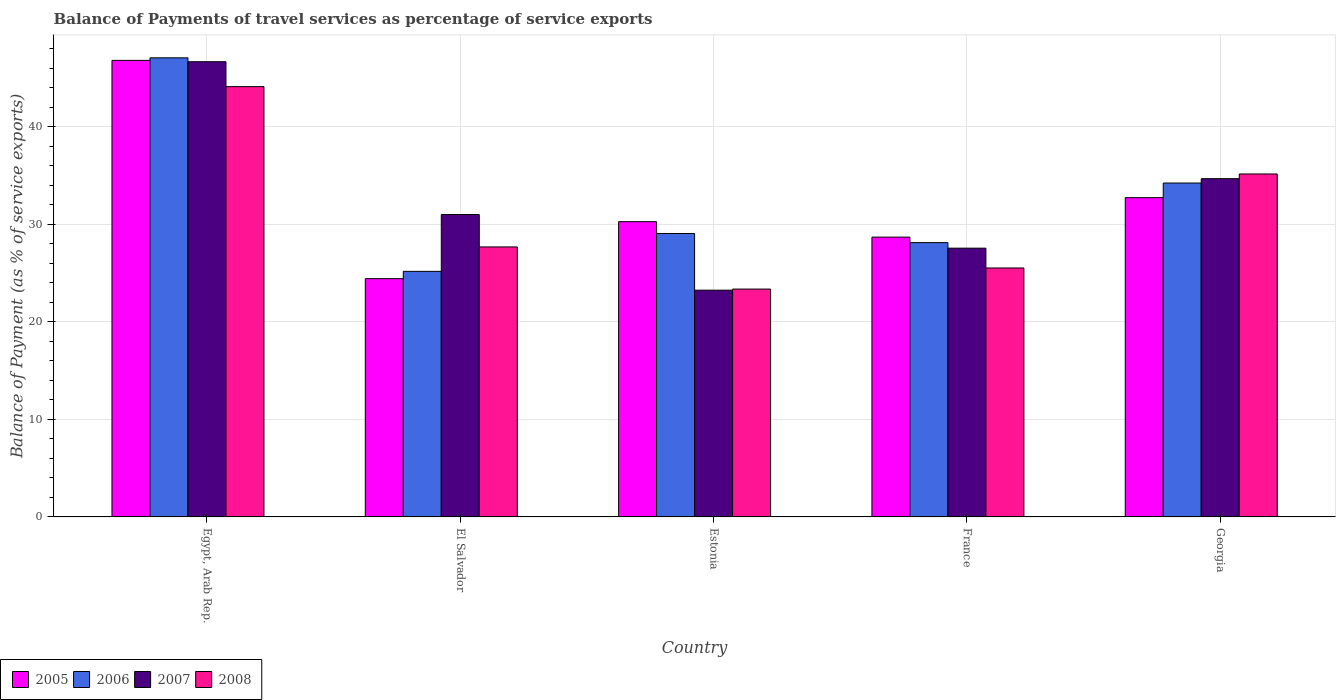Are the number of bars on each tick of the X-axis equal?
Offer a very short reply. Yes. How many bars are there on the 3rd tick from the left?
Your answer should be very brief. 4. What is the label of the 1st group of bars from the left?
Your response must be concise. Egypt, Arab Rep. In how many cases, is the number of bars for a given country not equal to the number of legend labels?
Your response must be concise. 0. What is the balance of payments of travel services in 2008 in Georgia?
Provide a short and direct response. 35.15. Across all countries, what is the maximum balance of payments of travel services in 2005?
Your response must be concise. 46.79. Across all countries, what is the minimum balance of payments of travel services in 2006?
Your answer should be compact. 25.17. In which country was the balance of payments of travel services in 2005 maximum?
Provide a short and direct response. Egypt, Arab Rep. In which country was the balance of payments of travel services in 2008 minimum?
Your answer should be compact. Estonia. What is the total balance of payments of travel services in 2007 in the graph?
Offer a very short reply. 163.08. What is the difference between the balance of payments of travel services in 2006 in El Salvador and that in France?
Offer a terse response. -2.95. What is the difference between the balance of payments of travel services in 2005 in France and the balance of payments of travel services in 2008 in Georgia?
Provide a short and direct response. -6.47. What is the average balance of payments of travel services in 2008 per country?
Keep it short and to the point. 31.15. What is the difference between the balance of payments of travel services of/in 2007 and balance of payments of travel services of/in 2006 in El Salvador?
Provide a short and direct response. 5.82. What is the ratio of the balance of payments of travel services in 2008 in Egypt, Arab Rep. to that in Georgia?
Offer a terse response. 1.25. Is the balance of payments of travel services in 2005 in Egypt, Arab Rep. less than that in France?
Provide a short and direct response. No. What is the difference between the highest and the second highest balance of payments of travel services in 2006?
Keep it short and to the point. 5.17. What is the difference between the highest and the lowest balance of payments of travel services in 2008?
Offer a terse response. 20.74. In how many countries, is the balance of payments of travel services in 2008 greater than the average balance of payments of travel services in 2008 taken over all countries?
Provide a short and direct response. 2. What does the 2nd bar from the left in El Salvador represents?
Offer a terse response. 2006. What does the 4th bar from the right in Egypt, Arab Rep. represents?
Your answer should be compact. 2005. Are all the bars in the graph horizontal?
Keep it short and to the point. No. Are the values on the major ticks of Y-axis written in scientific E-notation?
Your response must be concise. No. How many legend labels are there?
Give a very brief answer. 4. What is the title of the graph?
Your answer should be compact. Balance of Payments of travel services as percentage of service exports. What is the label or title of the Y-axis?
Your answer should be compact. Balance of Payment (as % of service exports). What is the Balance of Payment (as % of service exports) in 2005 in Egypt, Arab Rep.?
Offer a very short reply. 46.79. What is the Balance of Payment (as % of service exports) of 2006 in Egypt, Arab Rep.?
Your answer should be compact. 47.05. What is the Balance of Payment (as % of service exports) in 2007 in Egypt, Arab Rep.?
Provide a succinct answer. 46.65. What is the Balance of Payment (as % of service exports) in 2008 in Egypt, Arab Rep.?
Your response must be concise. 44.09. What is the Balance of Payment (as % of service exports) of 2005 in El Salvador?
Provide a succinct answer. 24.42. What is the Balance of Payment (as % of service exports) in 2006 in El Salvador?
Make the answer very short. 25.17. What is the Balance of Payment (as % of service exports) in 2007 in El Salvador?
Provide a succinct answer. 30.99. What is the Balance of Payment (as % of service exports) of 2008 in El Salvador?
Your response must be concise. 27.67. What is the Balance of Payment (as % of service exports) in 2005 in Estonia?
Offer a very short reply. 30.26. What is the Balance of Payment (as % of service exports) in 2006 in Estonia?
Ensure brevity in your answer.  29.04. What is the Balance of Payment (as % of service exports) in 2007 in Estonia?
Offer a very short reply. 23.24. What is the Balance of Payment (as % of service exports) of 2008 in Estonia?
Your answer should be compact. 23.35. What is the Balance of Payment (as % of service exports) in 2005 in France?
Ensure brevity in your answer.  28.67. What is the Balance of Payment (as % of service exports) in 2006 in France?
Offer a terse response. 28.11. What is the Balance of Payment (as % of service exports) in 2007 in France?
Your answer should be very brief. 27.54. What is the Balance of Payment (as % of service exports) in 2008 in France?
Make the answer very short. 25.51. What is the Balance of Payment (as % of service exports) of 2005 in Georgia?
Make the answer very short. 32.72. What is the Balance of Payment (as % of service exports) in 2006 in Georgia?
Offer a very short reply. 34.22. What is the Balance of Payment (as % of service exports) of 2007 in Georgia?
Your answer should be very brief. 34.66. What is the Balance of Payment (as % of service exports) of 2008 in Georgia?
Provide a succinct answer. 35.15. Across all countries, what is the maximum Balance of Payment (as % of service exports) in 2005?
Offer a very short reply. 46.79. Across all countries, what is the maximum Balance of Payment (as % of service exports) of 2006?
Offer a terse response. 47.05. Across all countries, what is the maximum Balance of Payment (as % of service exports) of 2007?
Provide a succinct answer. 46.65. Across all countries, what is the maximum Balance of Payment (as % of service exports) of 2008?
Provide a short and direct response. 44.09. Across all countries, what is the minimum Balance of Payment (as % of service exports) of 2005?
Your response must be concise. 24.42. Across all countries, what is the minimum Balance of Payment (as % of service exports) in 2006?
Give a very brief answer. 25.17. Across all countries, what is the minimum Balance of Payment (as % of service exports) in 2007?
Your answer should be compact. 23.24. Across all countries, what is the minimum Balance of Payment (as % of service exports) in 2008?
Your answer should be compact. 23.35. What is the total Balance of Payment (as % of service exports) of 2005 in the graph?
Ensure brevity in your answer.  162.86. What is the total Balance of Payment (as % of service exports) of 2006 in the graph?
Offer a very short reply. 163.58. What is the total Balance of Payment (as % of service exports) of 2007 in the graph?
Provide a short and direct response. 163.08. What is the total Balance of Payment (as % of service exports) in 2008 in the graph?
Provide a succinct answer. 155.77. What is the difference between the Balance of Payment (as % of service exports) of 2005 in Egypt, Arab Rep. and that in El Salvador?
Offer a very short reply. 22.37. What is the difference between the Balance of Payment (as % of service exports) in 2006 in Egypt, Arab Rep. and that in El Salvador?
Make the answer very short. 21.88. What is the difference between the Balance of Payment (as % of service exports) of 2007 in Egypt, Arab Rep. and that in El Salvador?
Ensure brevity in your answer.  15.66. What is the difference between the Balance of Payment (as % of service exports) of 2008 in Egypt, Arab Rep. and that in El Salvador?
Provide a succinct answer. 16.43. What is the difference between the Balance of Payment (as % of service exports) of 2005 in Egypt, Arab Rep. and that in Estonia?
Your answer should be very brief. 16.53. What is the difference between the Balance of Payment (as % of service exports) of 2006 in Egypt, Arab Rep. and that in Estonia?
Ensure brevity in your answer.  18. What is the difference between the Balance of Payment (as % of service exports) of 2007 in Egypt, Arab Rep. and that in Estonia?
Make the answer very short. 23.41. What is the difference between the Balance of Payment (as % of service exports) of 2008 in Egypt, Arab Rep. and that in Estonia?
Offer a very short reply. 20.74. What is the difference between the Balance of Payment (as % of service exports) in 2005 in Egypt, Arab Rep. and that in France?
Make the answer very short. 18.11. What is the difference between the Balance of Payment (as % of service exports) of 2006 in Egypt, Arab Rep. and that in France?
Your answer should be compact. 18.94. What is the difference between the Balance of Payment (as % of service exports) of 2007 in Egypt, Arab Rep. and that in France?
Make the answer very short. 19.11. What is the difference between the Balance of Payment (as % of service exports) in 2008 in Egypt, Arab Rep. and that in France?
Your response must be concise. 18.58. What is the difference between the Balance of Payment (as % of service exports) of 2005 in Egypt, Arab Rep. and that in Georgia?
Keep it short and to the point. 14.07. What is the difference between the Balance of Payment (as % of service exports) of 2006 in Egypt, Arab Rep. and that in Georgia?
Give a very brief answer. 12.83. What is the difference between the Balance of Payment (as % of service exports) of 2007 in Egypt, Arab Rep. and that in Georgia?
Your answer should be compact. 11.98. What is the difference between the Balance of Payment (as % of service exports) of 2008 in Egypt, Arab Rep. and that in Georgia?
Your response must be concise. 8.95. What is the difference between the Balance of Payment (as % of service exports) in 2005 in El Salvador and that in Estonia?
Ensure brevity in your answer.  -5.84. What is the difference between the Balance of Payment (as % of service exports) in 2006 in El Salvador and that in Estonia?
Offer a very short reply. -3.88. What is the difference between the Balance of Payment (as % of service exports) in 2007 in El Salvador and that in Estonia?
Your response must be concise. 7.75. What is the difference between the Balance of Payment (as % of service exports) of 2008 in El Salvador and that in Estonia?
Give a very brief answer. 4.32. What is the difference between the Balance of Payment (as % of service exports) in 2005 in El Salvador and that in France?
Keep it short and to the point. -4.26. What is the difference between the Balance of Payment (as % of service exports) of 2006 in El Salvador and that in France?
Your answer should be compact. -2.95. What is the difference between the Balance of Payment (as % of service exports) of 2007 in El Salvador and that in France?
Offer a very short reply. 3.45. What is the difference between the Balance of Payment (as % of service exports) of 2008 in El Salvador and that in France?
Offer a terse response. 2.16. What is the difference between the Balance of Payment (as % of service exports) in 2005 in El Salvador and that in Georgia?
Offer a very short reply. -8.3. What is the difference between the Balance of Payment (as % of service exports) in 2006 in El Salvador and that in Georgia?
Your answer should be compact. -9.05. What is the difference between the Balance of Payment (as % of service exports) in 2007 in El Salvador and that in Georgia?
Offer a very short reply. -3.67. What is the difference between the Balance of Payment (as % of service exports) in 2008 in El Salvador and that in Georgia?
Offer a very short reply. -7.48. What is the difference between the Balance of Payment (as % of service exports) of 2005 in Estonia and that in France?
Offer a terse response. 1.58. What is the difference between the Balance of Payment (as % of service exports) in 2006 in Estonia and that in France?
Your answer should be compact. 0.93. What is the difference between the Balance of Payment (as % of service exports) of 2007 in Estonia and that in France?
Your response must be concise. -4.31. What is the difference between the Balance of Payment (as % of service exports) in 2008 in Estonia and that in France?
Offer a very short reply. -2.16. What is the difference between the Balance of Payment (as % of service exports) in 2005 in Estonia and that in Georgia?
Give a very brief answer. -2.46. What is the difference between the Balance of Payment (as % of service exports) in 2006 in Estonia and that in Georgia?
Offer a terse response. -5.17. What is the difference between the Balance of Payment (as % of service exports) in 2007 in Estonia and that in Georgia?
Keep it short and to the point. -11.43. What is the difference between the Balance of Payment (as % of service exports) of 2008 in Estonia and that in Georgia?
Keep it short and to the point. -11.79. What is the difference between the Balance of Payment (as % of service exports) of 2005 in France and that in Georgia?
Ensure brevity in your answer.  -4.05. What is the difference between the Balance of Payment (as % of service exports) in 2006 in France and that in Georgia?
Your answer should be compact. -6.11. What is the difference between the Balance of Payment (as % of service exports) in 2007 in France and that in Georgia?
Give a very brief answer. -7.12. What is the difference between the Balance of Payment (as % of service exports) in 2008 in France and that in Georgia?
Provide a succinct answer. -9.63. What is the difference between the Balance of Payment (as % of service exports) in 2005 in Egypt, Arab Rep. and the Balance of Payment (as % of service exports) in 2006 in El Salvador?
Your answer should be compact. 21.62. What is the difference between the Balance of Payment (as % of service exports) of 2005 in Egypt, Arab Rep. and the Balance of Payment (as % of service exports) of 2007 in El Salvador?
Make the answer very short. 15.8. What is the difference between the Balance of Payment (as % of service exports) in 2005 in Egypt, Arab Rep. and the Balance of Payment (as % of service exports) in 2008 in El Salvador?
Offer a terse response. 19.12. What is the difference between the Balance of Payment (as % of service exports) of 2006 in Egypt, Arab Rep. and the Balance of Payment (as % of service exports) of 2007 in El Salvador?
Ensure brevity in your answer.  16.06. What is the difference between the Balance of Payment (as % of service exports) in 2006 in Egypt, Arab Rep. and the Balance of Payment (as % of service exports) in 2008 in El Salvador?
Offer a very short reply. 19.38. What is the difference between the Balance of Payment (as % of service exports) in 2007 in Egypt, Arab Rep. and the Balance of Payment (as % of service exports) in 2008 in El Salvador?
Your response must be concise. 18.98. What is the difference between the Balance of Payment (as % of service exports) in 2005 in Egypt, Arab Rep. and the Balance of Payment (as % of service exports) in 2006 in Estonia?
Offer a very short reply. 17.74. What is the difference between the Balance of Payment (as % of service exports) in 2005 in Egypt, Arab Rep. and the Balance of Payment (as % of service exports) in 2007 in Estonia?
Provide a succinct answer. 23.55. What is the difference between the Balance of Payment (as % of service exports) of 2005 in Egypt, Arab Rep. and the Balance of Payment (as % of service exports) of 2008 in Estonia?
Offer a terse response. 23.43. What is the difference between the Balance of Payment (as % of service exports) of 2006 in Egypt, Arab Rep. and the Balance of Payment (as % of service exports) of 2007 in Estonia?
Offer a terse response. 23.81. What is the difference between the Balance of Payment (as % of service exports) in 2006 in Egypt, Arab Rep. and the Balance of Payment (as % of service exports) in 2008 in Estonia?
Offer a terse response. 23.7. What is the difference between the Balance of Payment (as % of service exports) of 2007 in Egypt, Arab Rep. and the Balance of Payment (as % of service exports) of 2008 in Estonia?
Offer a terse response. 23.3. What is the difference between the Balance of Payment (as % of service exports) of 2005 in Egypt, Arab Rep. and the Balance of Payment (as % of service exports) of 2006 in France?
Keep it short and to the point. 18.67. What is the difference between the Balance of Payment (as % of service exports) of 2005 in Egypt, Arab Rep. and the Balance of Payment (as % of service exports) of 2007 in France?
Offer a very short reply. 19.24. What is the difference between the Balance of Payment (as % of service exports) of 2005 in Egypt, Arab Rep. and the Balance of Payment (as % of service exports) of 2008 in France?
Offer a terse response. 21.27. What is the difference between the Balance of Payment (as % of service exports) of 2006 in Egypt, Arab Rep. and the Balance of Payment (as % of service exports) of 2007 in France?
Provide a succinct answer. 19.5. What is the difference between the Balance of Payment (as % of service exports) of 2006 in Egypt, Arab Rep. and the Balance of Payment (as % of service exports) of 2008 in France?
Provide a succinct answer. 21.53. What is the difference between the Balance of Payment (as % of service exports) in 2007 in Egypt, Arab Rep. and the Balance of Payment (as % of service exports) in 2008 in France?
Give a very brief answer. 21.14. What is the difference between the Balance of Payment (as % of service exports) of 2005 in Egypt, Arab Rep. and the Balance of Payment (as % of service exports) of 2006 in Georgia?
Your answer should be very brief. 12.57. What is the difference between the Balance of Payment (as % of service exports) in 2005 in Egypt, Arab Rep. and the Balance of Payment (as % of service exports) in 2007 in Georgia?
Provide a short and direct response. 12.12. What is the difference between the Balance of Payment (as % of service exports) in 2005 in Egypt, Arab Rep. and the Balance of Payment (as % of service exports) in 2008 in Georgia?
Ensure brevity in your answer.  11.64. What is the difference between the Balance of Payment (as % of service exports) in 2006 in Egypt, Arab Rep. and the Balance of Payment (as % of service exports) in 2007 in Georgia?
Keep it short and to the point. 12.38. What is the difference between the Balance of Payment (as % of service exports) of 2006 in Egypt, Arab Rep. and the Balance of Payment (as % of service exports) of 2008 in Georgia?
Ensure brevity in your answer.  11.9. What is the difference between the Balance of Payment (as % of service exports) of 2007 in Egypt, Arab Rep. and the Balance of Payment (as % of service exports) of 2008 in Georgia?
Provide a short and direct response. 11.5. What is the difference between the Balance of Payment (as % of service exports) of 2005 in El Salvador and the Balance of Payment (as % of service exports) of 2006 in Estonia?
Give a very brief answer. -4.63. What is the difference between the Balance of Payment (as % of service exports) of 2005 in El Salvador and the Balance of Payment (as % of service exports) of 2007 in Estonia?
Offer a terse response. 1.18. What is the difference between the Balance of Payment (as % of service exports) in 2005 in El Salvador and the Balance of Payment (as % of service exports) in 2008 in Estonia?
Provide a succinct answer. 1.07. What is the difference between the Balance of Payment (as % of service exports) of 2006 in El Salvador and the Balance of Payment (as % of service exports) of 2007 in Estonia?
Keep it short and to the point. 1.93. What is the difference between the Balance of Payment (as % of service exports) of 2006 in El Salvador and the Balance of Payment (as % of service exports) of 2008 in Estonia?
Provide a succinct answer. 1.81. What is the difference between the Balance of Payment (as % of service exports) in 2007 in El Salvador and the Balance of Payment (as % of service exports) in 2008 in Estonia?
Offer a very short reply. 7.64. What is the difference between the Balance of Payment (as % of service exports) of 2005 in El Salvador and the Balance of Payment (as % of service exports) of 2006 in France?
Keep it short and to the point. -3.69. What is the difference between the Balance of Payment (as % of service exports) in 2005 in El Salvador and the Balance of Payment (as % of service exports) in 2007 in France?
Provide a succinct answer. -3.12. What is the difference between the Balance of Payment (as % of service exports) in 2005 in El Salvador and the Balance of Payment (as % of service exports) in 2008 in France?
Your answer should be very brief. -1.09. What is the difference between the Balance of Payment (as % of service exports) in 2006 in El Salvador and the Balance of Payment (as % of service exports) in 2007 in France?
Your answer should be compact. -2.38. What is the difference between the Balance of Payment (as % of service exports) of 2006 in El Salvador and the Balance of Payment (as % of service exports) of 2008 in France?
Your answer should be very brief. -0.35. What is the difference between the Balance of Payment (as % of service exports) in 2007 in El Salvador and the Balance of Payment (as % of service exports) in 2008 in France?
Give a very brief answer. 5.48. What is the difference between the Balance of Payment (as % of service exports) of 2005 in El Salvador and the Balance of Payment (as % of service exports) of 2006 in Georgia?
Offer a very short reply. -9.8. What is the difference between the Balance of Payment (as % of service exports) in 2005 in El Salvador and the Balance of Payment (as % of service exports) in 2007 in Georgia?
Your answer should be compact. -10.25. What is the difference between the Balance of Payment (as % of service exports) of 2005 in El Salvador and the Balance of Payment (as % of service exports) of 2008 in Georgia?
Your answer should be very brief. -10.73. What is the difference between the Balance of Payment (as % of service exports) in 2006 in El Salvador and the Balance of Payment (as % of service exports) in 2007 in Georgia?
Give a very brief answer. -9.5. What is the difference between the Balance of Payment (as % of service exports) of 2006 in El Salvador and the Balance of Payment (as % of service exports) of 2008 in Georgia?
Offer a very short reply. -9.98. What is the difference between the Balance of Payment (as % of service exports) of 2007 in El Salvador and the Balance of Payment (as % of service exports) of 2008 in Georgia?
Your response must be concise. -4.16. What is the difference between the Balance of Payment (as % of service exports) in 2005 in Estonia and the Balance of Payment (as % of service exports) in 2006 in France?
Offer a terse response. 2.15. What is the difference between the Balance of Payment (as % of service exports) in 2005 in Estonia and the Balance of Payment (as % of service exports) in 2007 in France?
Make the answer very short. 2.72. What is the difference between the Balance of Payment (as % of service exports) in 2005 in Estonia and the Balance of Payment (as % of service exports) in 2008 in France?
Your answer should be very brief. 4.75. What is the difference between the Balance of Payment (as % of service exports) in 2006 in Estonia and the Balance of Payment (as % of service exports) in 2007 in France?
Offer a very short reply. 1.5. What is the difference between the Balance of Payment (as % of service exports) in 2006 in Estonia and the Balance of Payment (as % of service exports) in 2008 in France?
Keep it short and to the point. 3.53. What is the difference between the Balance of Payment (as % of service exports) in 2007 in Estonia and the Balance of Payment (as % of service exports) in 2008 in France?
Give a very brief answer. -2.28. What is the difference between the Balance of Payment (as % of service exports) of 2005 in Estonia and the Balance of Payment (as % of service exports) of 2006 in Georgia?
Provide a short and direct response. -3.96. What is the difference between the Balance of Payment (as % of service exports) of 2005 in Estonia and the Balance of Payment (as % of service exports) of 2007 in Georgia?
Provide a short and direct response. -4.41. What is the difference between the Balance of Payment (as % of service exports) in 2005 in Estonia and the Balance of Payment (as % of service exports) in 2008 in Georgia?
Keep it short and to the point. -4.89. What is the difference between the Balance of Payment (as % of service exports) of 2006 in Estonia and the Balance of Payment (as % of service exports) of 2007 in Georgia?
Your answer should be compact. -5.62. What is the difference between the Balance of Payment (as % of service exports) of 2006 in Estonia and the Balance of Payment (as % of service exports) of 2008 in Georgia?
Your response must be concise. -6.1. What is the difference between the Balance of Payment (as % of service exports) of 2007 in Estonia and the Balance of Payment (as % of service exports) of 2008 in Georgia?
Offer a terse response. -11.91. What is the difference between the Balance of Payment (as % of service exports) in 2005 in France and the Balance of Payment (as % of service exports) in 2006 in Georgia?
Give a very brief answer. -5.54. What is the difference between the Balance of Payment (as % of service exports) in 2005 in France and the Balance of Payment (as % of service exports) in 2007 in Georgia?
Keep it short and to the point. -5.99. What is the difference between the Balance of Payment (as % of service exports) of 2005 in France and the Balance of Payment (as % of service exports) of 2008 in Georgia?
Your answer should be very brief. -6.47. What is the difference between the Balance of Payment (as % of service exports) of 2006 in France and the Balance of Payment (as % of service exports) of 2007 in Georgia?
Your answer should be very brief. -6.55. What is the difference between the Balance of Payment (as % of service exports) in 2006 in France and the Balance of Payment (as % of service exports) in 2008 in Georgia?
Ensure brevity in your answer.  -7.03. What is the difference between the Balance of Payment (as % of service exports) in 2007 in France and the Balance of Payment (as % of service exports) in 2008 in Georgia?
Your answer should be compact. -7.6. What is the average Balance of Payment (as % of service exports) in 2005 per country?
Ensure brevity in your answer.  32.57. What is the average Balance of Payment (as % of service exports) of 2006 per country?
Make the answer very short. 32.72. What is the average Balance of Payment (as % of service exports) in 2007 per country?
Keep it short and to the point. 32.62. What is the average Balance of Payment (as % of service exports) of 2008 per country?
Give a very brief answer. 31.15. What is the difference between the Balance of Payment (as % of service exports) of 2005 and Balance of Payment (as % of service exports) of 2006 in Egypt, Arab Rep.?
Offer a terse response. -0.26. What is the difference between the Balance of Payment (as % of service exports) in 2005 and Balance of Payment (as % of service exports) in 2007 in Egypt, Arab Rep.?
Ensure brevity in your answer.  0.14. What is the difference between the Balance of Payment (as % of service exports) in 2005 and Balance of Payment (as % of service exports) in 2008 in Egypt, Arab Rep.?
Provide a succinct answer. 2.69. What is the difference between the Balance of Payment (as % of service exports) of 2006 and Balance of Payment (as % of service exports) of 2007 in Egypt, Arab Rep.?
Your response must be concise. 0.4. What is the difference between the Balance of Payment (as % of service exports) in 2006 and Balance of Payment (as % of service exports) in 2008 in Egypt, Arab Rep.?
Your answer should be very brief. 2.95. What is the difference between the Balance of Payment (as % of service exports) of 2007 and Balance of Payment (as % of service exports) of 2008 in Egypt, Arab Rep.?
Make the answer very short. 2.55. What is the difference between the Balance of Payment (as % of service exports) in 2005 and Balance of Payment (as % of service exports) in 2006 in El Salvador?
Your answer should be compact. -0.75. What is the difference between the Balance of Payment (as % of service exports) in 2005 and Balance of Payment (as % of service exports) in 2007 in El Salvador?
Give a very brief answer. -6.57. What is the difference between the Balance of Payment (as % of service exports) in 2005 and Balance of Payment (as % of service exports) in 2008 in El Salvador?
Give a very brief answer. -3.25. What is the difference between the Balance of Payment (as % of service exports) in 2006 and Balance of Payment (as % of service exports) in 2007 in El Salvador?
Provide a short and direct response. -5.82. What is the difference between the Balance of Payment (as % of service exports) of 2006 and Balance of Payment (as % of service exports) of 2008 in El Salvador?
Offer a very short reply. -2.5. What is the difference between the Balance of Payment (as % of service exports) in 2007 and Balance of Payment (as % of service exports) in 2008 in El Salvador?
Offer a terse response. 3.32. What is the difference between the Balance of Payment (as % of service exports) of 2005 and Balance of Payment (as % of service exports) of 2006 in Estonia?
Your answer should be compact. 1.21. What is the difference between the Balance of Payment (as % of service exports) of 2005 and Balance of Payment (as % of service exports) of 2007 in Estonia?
Your response must be concise. 7.02. What is the difference between the Balance of Payment (as % of service exports) of 2005 and Balance of Payment (as % of service exports) of 2008 in Estonia?
Ensure brevity in your answer.  6.91. What is the difference between the Balance of Payment (as % of service exports) in 2006 and Balance of Payment (as % of service exports) in 2007 in Estonia?
Make the answer very short. 5.81. What is the difference between the Balance of Payment (as % of service exports) of 2006 and Balance of Payment (as % of service exports) of 2008 in Estonia?
Offer a very short reply. 5.69. What is the difference between the Balance of Payment (as % of service exports) in 2007 and Balance of Payment (as % of service exports) in 2008 in Estonia?
Your answer should be very brief. -0.11. What is the difference between the Balance of Payment (as % of service exports) of 2005 and Balance of Payment (as % of service exports) of 2006 in France?
Your answer should be very brief. 0.56. What is the difference between the Balance of Payment (as % of service exports) in 2005 and Balance of Payment (as % of service exports) in 2007 in France?
Provide a succinct answer. 1.13. What is the difference between the Balance of Payment (as % of service exports) in 2005 and Balance of Payment (as % of service exports) in 2008 in France?
Provide a short and direct response. 3.16. What is the difference between the Balance of Payment (as % of service exports) of 2006 and Balance of Payment (as % of service exports) of 2007 in France?
Your response must be concise. 0.57. What is the difference between the Balance of Payment (as % of service exports) in 2006 and Balance of Payment (as % of service exports) in 2008 in France?
Make the answer very short. 2.6. What is the difference between the Balance of Payment (as % of service exports) of 2007 and Balance of Payment (as % of service exports) of 2008 in France?
Keep it short and to the point. 2.03. What is the difference between the Balance of Payment (as % of service exports) of 2005 and Balance of Payment (as % of service exports) of 2006 in Georgia?
Ensure brevity in your answer.  -1.5. What is the difference between the Balance of Payment (as % of service exports) of 2005 and Balance of Payment (as % of service exports) of 2007 in Georgia?
Make the answer very short. -1.94. What is the difference between the Balance of Payment (as % of service exports) in 2005 and Balance of Payment (as % of service exports) in 2008 in Georgia?
Your answer should be compact. -2.43. What is the difference between the Balance of Payment (as % of service exports) of 2006 and Balance of Payment (as % of service exports) of 2007 in Georgia?
Provide a short and direct response. -0.45. What is the difference between the Balance of Payment (as % of service exports) of 2006 and Balance of Payment (as % of service exports) of 2008 in Georgia?
Your answer should be very brief. -0.93. What is the difference between the Balance of Payment (as % of service exports) of 2007 and Balance of Payment (as % of service exports) of 2008 in Georgia?
Your answer should be very brief. -0.48. What is the ratio of the Balance of Payment (as % of service exports) of 2005 in Egypt, Arab Rep. to that in El Salvador?
Provide a short and direct response. 1.92. What is the ratio of the Balance of Payment (as % of service exports) in 2006 in Egypt, Arab Rep. to that in El Salvador?
Offer a terse response. 1.87. What is the ratio of the Balance of Payment (as % of service exports) of 2007 in Egypt, Arab Rep. to that in El Salvador?
Offer a terse response. 1.51. What is the ratio of the Balance of Payment (as % of service exports) in 2008 in Egypt, Arab Rep. to that in El Salvador?
Your response must be concise. 1.59. What is the ratio of the Balance of Payment (as % of service exports) of 2005 in Egypt, Arab Rep. to that in Estonia?
Offer a terse response. 1.55. What is the ratio of the Balance of Payment (as % of service exports) in 2006 in Egypt, Arab Rep. to that in Estonia?
Your answer should be compact. 1.62. What is the ratio of the Balance of Payment (as % of service exports) of 2007 in Egypt, Arab Rep. to that in Estonia?
Give a very brief answer. 2.01. What is the ratio of the Balance of Payment (as % of service exports) in 2008 in Egypt, Arab Rep. to that in Estonia?
Ensure brevity in your answer.  1.89. What is the ratio of the Balance of Payment (as % of service exports) of 2005 in Egypt, Arab Rep. to that in France?
Offer a terse response. 1.63. What is the ratio of the Balance of Payment (as % of service exports) of 2006 in Egypt, Arab Rep. to that in France?
Provide a succinct answer. 1.67. What is the ratio of the Balance of Payment (as % of service exports) of 2007 in Egypt, Arab Rep. to that in France?
Give a very brief answer. 1.69. What is the ratio of the Balance of Payment (as % of service exports) of 2008 in Egypt, Arab Rep. to that in France?
Give a very brief answer. 1.73. What is the ratio of the Balance of Payment (as % of service exports) in 2005 in Egypt, Arab Rep. to that in Georgia?
Make the answer very short. 1.43. What is the ratio of the Balance of Payment (as % of service exports) in 2006 in Egypt, Arab Rep. to that in Georgia?
Provide a succinct answer. 1.38. What is the ratio of the Balance of Payment (as % of service exports) in 2007 in Egypt, Arab Rep. to that in Georgia?
Give a very brief answer. 1.35. What is the ratio of the Balance of Payment (as % of service exports) of 2008 in Egypt, Arab Rep. to that in Georgia?
Offer a terse response. 1.25. What is the ratio of the Balance of Payment (as % of service exports) of 2005 in El Salvador to that in Estonia?
Offer a very short reply. 0.81. What is the ratio of the Balance of Payment (as % of service exports) of 2006 in El Salvador to that in Estonia?
Make the answer very short. 0.87. What is the ratio of the Balance of Payment (as % of service exports) of 2007 in El Salvador to that in Estonia?
Provide a succinct answer. 1.33. What is the ratio of the Balance of Payment (as % of service exports) of 2008 in El Salvador to that in Estonia?
Make the answer very short. 1.18. What is the ratio of the Balance of Payment (as % of service exports) in 2005 in El Salvador to that in France?
Your response must be concise. 0.85. What is the ratio of the Balance of Payment (as % of service exports) in 2006 in El Salvador to that in France?
Your answer should be compact. 0.9. What is the ratio of the Balance of Payment (as % of service exports) in 2007 in El Salvador to that in France?
Provide a succinct answer. 1.13. What is the ratio of the Balance of Payment (as % of service exports) of 2008 in El Salvador to that in France?
Your response must be concise. 1.08. What is the ratio of the Balance of Payment (as % of service exports) in 2005 in El Salvador to that in Georgia?
Your answer should be compact. 0.75. What is the ratio of the Balance of Payment (as % of service exports) of 2006 in El Salvador to that in Georgia?
Your answer should be very brief. 0.74. What is the ratio of the Balance of Payment (as % of service exports) in 2007 in El Salvador to that in Georgia?
Keep it short and to the point. 0.89. What is the ratio of the Balance of Payment (as % of service exports) in 2008 in El Salvador to that in Georgia?
Your response must be concise. 0.79. What is the ratio of the Balance of Payment (as % of service exports) of 2005 in Estonia to that in France?
Your answer should be very brief. 1.06. What is the ratio of the Balance of Payment (as % of service exports) in 2006 in Estonia to that in France?
Your answer should be very brief. 1.03. What is the ratio of the Balance of Payment (as % of service exports) of 2007 in Estonia to that in France?
Ensure brevity in your answer.  0.84. What is the ratio of the Balance of Payment (as % of service exports) in 2008 in Estonia to that in France?
Make the answer very short. 0.92. What is the ratio of the Balance of Payment (as % of service exports) in 2005 in Estonia to that in Georgia?
Keep it short and to the point. 0.92. What is the ratio of the Balance of Payment (as % of service exports) of 2006 in Estonia to that in Georgia?
Give a very brief answer. 0.85. What is the ratio of the Balance of Payment (as % of service exports) in 2007 in Estonia to that in Georgia?
Keep it short and to the point. 0.67. What is the ratio of the Balance of Payment (as % of service exports) in 2008 in Estonia to that in Georgia?
Ensure brevity in your answer.  0.66. What is the ratio of the Balance of Payment (as % of service exports) in 2005 in France to that in Georgia?
Offer a very short reply. 0.88. What is the ratio of the Balance of Payment (as % of service exports) in 2006 in France to that in Georgia?
Provide a short and direct response. 0.82. What is the ratio of the Balance of Payment (as % of service exports) in 2007 in France to that in Georgia?
Your response must be concise. 0.79. What is the ratio of the Balance of Payment (as % of service exports) in 2008 in France to that in Georgia?
Your answer should be compact. 0.73. What is the difference between the highest and the second highest Balance of Payment (as % of service exports) in 2005?
Give a very brief answer. 14.07. What is the difference between the highest and the second highest Balance of Payment (as % of service exports) in 2006?
Offer a terse response. 12.83. What is the difference between the highest and the second highest Balance of Payment (as % of service exports) of 2007?
Provide a short and direct response. 11.98. What is the difference between the highest and the second highest Balance of Payment (as % of service exports) in 2008?
Provide a short and direct response. 8.95. What is the difference between the highest and the lowest Balance of Payment (as % of service exports) in 2005?
Provide a short and direct response. 22.37. What is the difference between the highest and the lowest Balance of Payment (as % of service exports) of 2006?
Keep it short and to the point. 21.88. What is the difference between the highest and the lowest Balance of Payment (as % of service exports) in 2007?
Offer a terse response. 23.41. What is the difference between the highest and the lowest Balance of Payment (as % of service exports) of 2008?
Your answer should be compact. 20.74. 